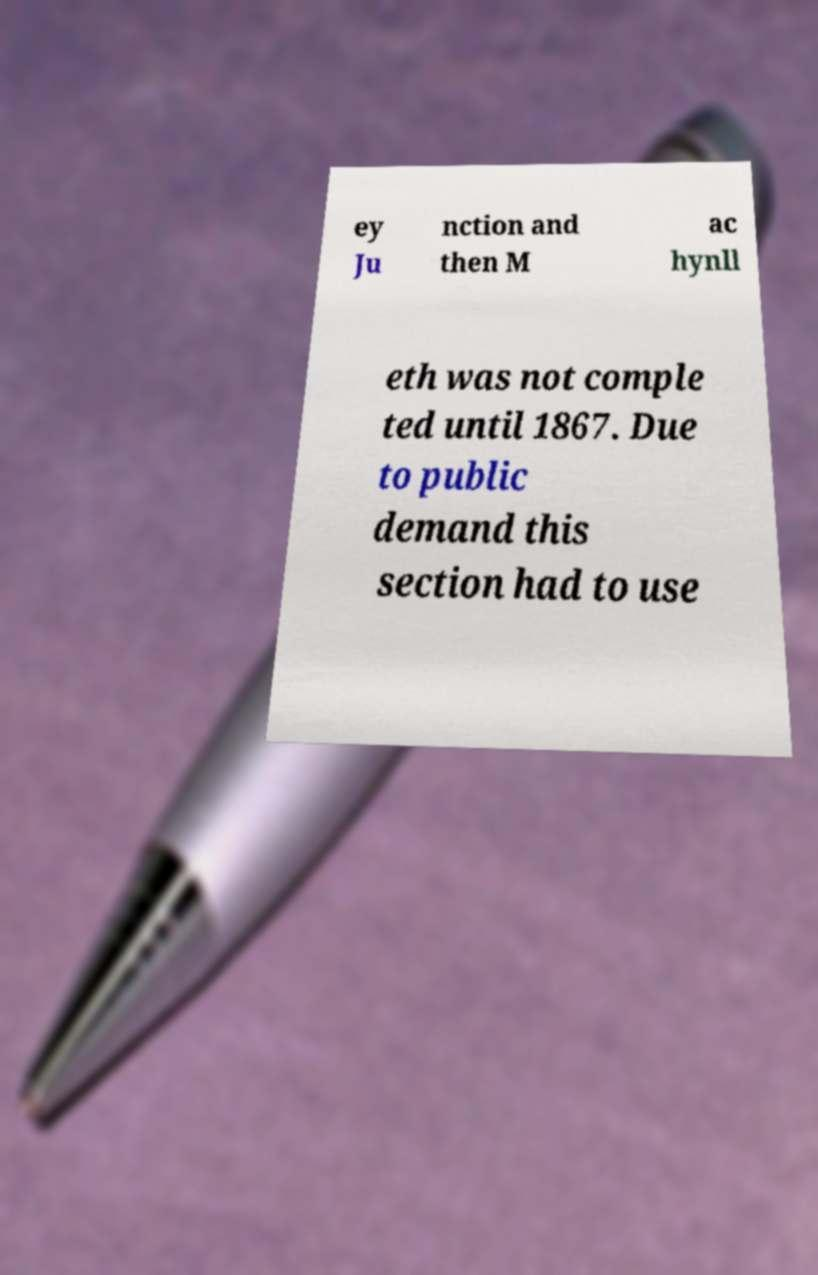There's text embedded in this image that I need extracted. Can you transcribe it verbatim? ey Ju nction and then M ac hynll eth was not comple ted until 1867. Due to public demand this section had to use 